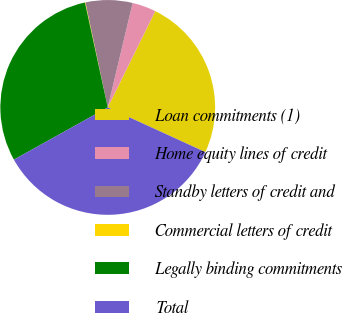Convert chart to OTSL. <chart><loc_0><loc_0><loc_500><loc_500><pie_chart><fcel>Loan commitments (1)<fcel>Home equity lines of credit<fcel>Standby letters of credit and<fcel>Commercial letters of credit<fcel>Legally binding commitments<fcel>Total<nl><fcel>24.53%<fcel>3.57%<fcel>7.07%<fcel>0.07%<fcel>29.67%<fcel>35.08%<nl></chart> 